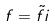<formula> <loc_0><loc_0><loc_500><loc_500>f = \tilde { f } i</formula> 